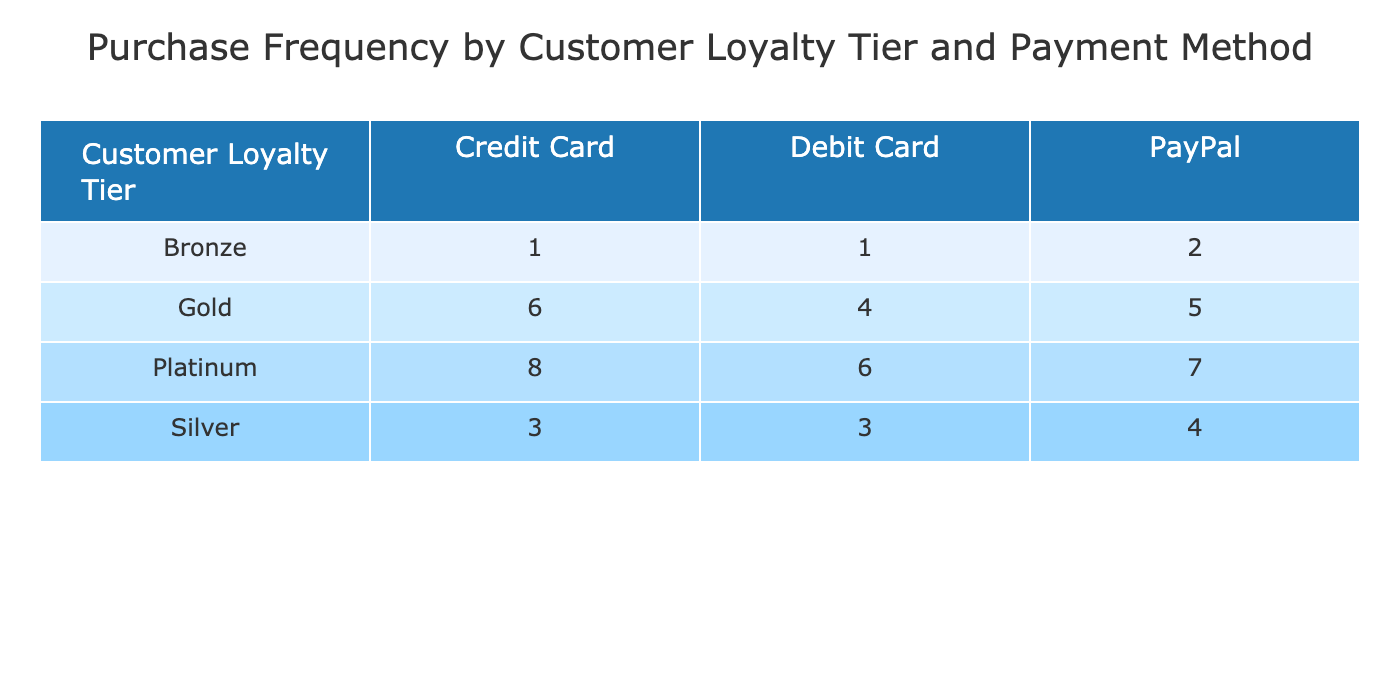What is the total purchase frequency for customers in the Gold tier using PayPal? In the table, we look at the Gold tier and the PayPal column. The purchase frequency listed for Gold with PayPal is 5. There is no need for further calculation as this is a direct retrieval from the table.
Answer: 5 Which payment method has the highest total purchase frequency across all customer loyalty tiers? We need to sum the purchase frequency for each payment method across all tiers. For Credit Card: (1 + 3 + 6 + 8) = 18, for PayPal: (2 + 4 + 5 + 7) = 18, and for Debit Card: (1 + 3 + 4 + 6) = 14. Both Credit Card and PayPal have the highest total of 18, but since there are two methods with the same total, they are equal.
Answer: Credit Card and PayPal Is there any customer loyalty tier where the Debit Card is the preferred payment method? By examining the Debit Card column in each loyalty tier, we see the following frequencies: Bronze (1), Silver (3), Gold (4), and Platinum (6). Since there are values greater than zero, this indicates that Debit Card is indeed a preferred payment method for all tiers.
Answer: Yes Which customer loyalty tier has the lowest purchase frequency for Credit Card payment? Checking the Credit Card row for each tier yields: Bronze (1), Silver (3), Gold (6), and Platinum (8). The Bronze tier has the lowest frequency for Credit Card purchases, which is 1.
Answer: Bronze What is the average purchase frequency for the Platinum tier? For the Platinum tier, the purchase frequencies are: Credit Card (8), PayPal (7), and Debit Card (6). The total is 8 + 7 + 6 = 21. There are 3 payment methods, so the average is 21 / 3 = 7.
Answer: 7 What is the difference in total purchase frequency between Silver and Gold tiers? Summing the purchase frequencies: Silver has (3 + 4 + 3) = 10 and Gold has (6 + 5 + 4) = 15. The difference is calculated as 15 - 10 = 5.
Answer: 5 Does the Bronze tier have a higher total purchase frequency compared to the Silver tier? After summing the frequencies, Bronze totals to (1 + 2 + 1) = 4, and Silver totals to (3 + 4 + 3) = 10. Since 4 is less than 10, the Bronze tier does not have a higher total frequency.
Answer: No Which payment method contributed the most to the total purchase frequency in the Silver tier? In the Silver tier, the purchase frequencies are: Credit Card (3), PayPal (4), and Debit Card (3). The highest purchase frequency is 4 for PayPal, thus it contributed the most to the Silver tier total.
Answer: PayPal 